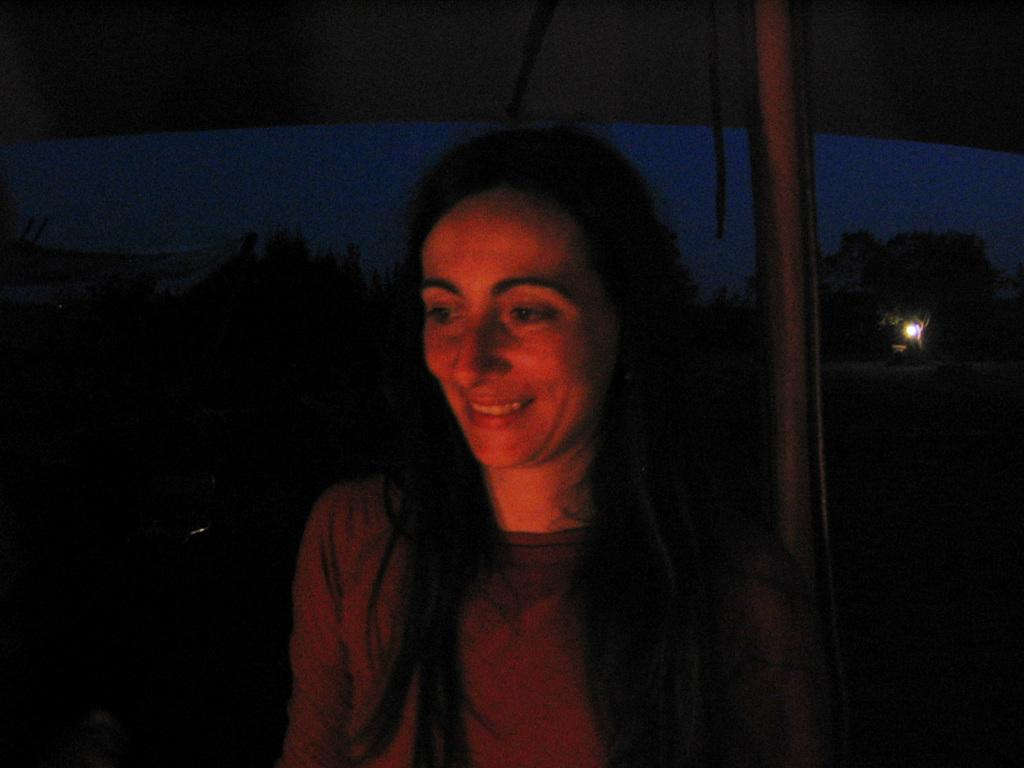What is the overall lighting condition of the image? The image is dark. Despite the darkness, is there any source of light visible in the image? Yes, there is a light visible in the image. What is the woman in the image doing? The woman is standing near a pole in the image. How does the woman appear to be feeling in the image? The woman is smiling in the image. What type of ticket is the woman holding in the image? There is no ticket visible in the image, and the woman is not holding anything. What shape is the pole that the woman is standing near? The facts provided do not mention the shape of the pole, so it cannot be determined from the image. 